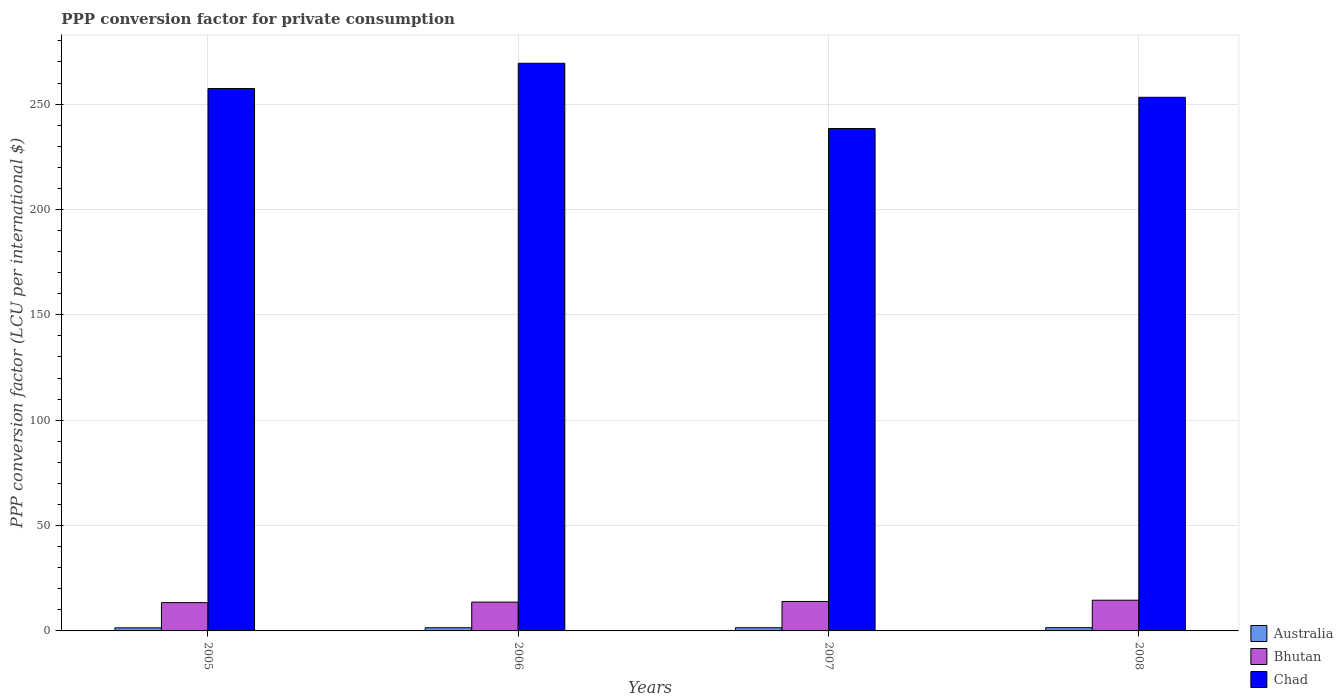How many different coloured bars are there?
Keep it short and to the point. 3. How many groups of bars are there?
Make the answer very short. 4. Are the number of bars per tick equal to the number of legend labels?
Provide a short and direct response. Yes. What is the label of the 4th group of bars from the left?
Provide a short and direct response. 2008. In how many cases, is the number of bars for a given year not equal to the number of legend labels?
Your answer should be very brief. 0. What is the PPP conversion factor for private consumption in Australia in 2007?
Make the answer very short. 1.51. Across all years, what is the maximum PPP conversion factor for private consumption in Australia?
Your answer should be compact. 1.53. Across all years, what is the minimum PPP conversion factor for private consumption in Bhutan?
Provide a succinct answer. 13.43. In which year was the PPP conversion factor for private consumption in Australia maximum?
Offer a very short reply. 2008. What is the total PPP conversion factor for private consumption in Australia in the graph?
Offer a terse response. 6. What is the difference between the PPP conversion factor for private consumption in Australia in 2006 and that in 2008?
Provide a succinct answer. -0.03. What is the difference between the PPP conversion factor for private consumption in Chad in 2005 and the PPP conversion factor for private consumption in Australia in 2006?
Give a very brief answer. 255.88. What is the average PPP conversion factor for private consumption in Bhutan per year?
Your answer should be very brief. 13.91. In the year 2008, what is the difference between the PPP conversion factor for private consumption in Chad and PPP conversion factor for private consumption in Australia?
Make the answer very short. 251.7. What is the ratio of the PPP conversion factor for private consumption in Chad in 2005 to that in 2007?
Make the answer very short. 1.08. Is the difference between the PPP conversion factor for private consumption in Chad in 2007 and 2008 greater than the difference between the PPP conversion factor for private consumption in Australia in 2007 and 2008?
Make the answer very short. No. What is the difference between the highest and the second highest PPP conversion factor for private consumption in Chad?
Your answer should be compact. 11.99. What is the difference between the highest and the lowest PPP conversion factor for private consumption in Australia?
Offer a very short reply. 0.07. In how many years, is the PPP conversion factor for private consumption in Chad greater than the average PPP conversion factor for private consumption in Chad taken over all years?
Offer a very short reply. 2. What does the 1st bar from the left in 2007 represents?
Give a very brief answer. Australia. What does the 1st bar from the right in 2008 represents?
Your answer should be very brief. Chad. How many years are there in the graph?
Your answer should be compact. 4. Are the values on the major ticks of Y-axis written in scientific E-notation?
Your answer should be very brief. No. Does the graph contain any zero values?
Provide a short and direct response. No. Does the graph contain grids?
Ensure brevity in your answer.  Yes. How many legend labels are there?
Your response must be concise. 3. How are the legend labels stacked?
Your answer should be very brief. Vertical. What is the title of the graph?
Make the answer very short. PPP conversion factor for private consumption. What is the label or title of the X-axis?
Make the answer very short. Years. What is the label or title of the Y-axis?
Offer a very short reply. PPP conversion factor (LCU per international $). What is the PPP conversion factor (LCU per international $) of Australia in 2005?
Offer a terse response. 1.46. What is the PPP conversion factor (LCU per international $) of Bhutan in 2005?
Ensure brevity in your answer.  13.43. What is the PPP conversion factor (LCU per international $) in Chad in 2005?
Offer a very short reply. 257.38. What is the PPP conversion factor (LCU per international $) of Australia in 2006?
Offer a terse response. 1.5. What is the PPP conversion factor (LCU per international $) of Bhutan in 2006?
Your answer should be very brief. 13.67. What is the PPP conversion factor (LCU per international $) in Chad in 2006?
Your answer should be very brief. 269.38. What is the PPP conversion factor (LCU per international $) in Australia in 2007?
Give a very brief answer. 1.51. What is the PPP conversion factor (LCU per international $) of Bhutan in 2007?
Provide a succinct answer. 13.97. What is the PPP conversion factor (LCU per international $) in Chad in 2007?
Provide a succinct answer. 238.4. What is the PPP conversion factor (LCU per international $) in Australia in 2008?
Offer a terse response. 1.53. What is the PPP conversion factor (LCU per international $) in Bhutan in 2008?
Keep it short and to the point. 14.58. What is the PPP conversion factor (LCU per international $) in Chad in 2008?
Offer a terse response. 253.23. Across all years, what is the maximum PPP conversion factor (LCU per international $) of Australia?
Offer a terse response. 1.53. Across all years, what is the maximum PPP conversion factor (LCU per international $) of Bhutan?
Give a very brief answer. 14.58. Across all years, what is the maximum PPP conversion factor (LCU per international $) in Chad?
Ensure brevity in your answer.  269.38. Across all years, what is the minimum PPP conversion factor (LCU per international $) in Australia?
Make the answer very short. 1.46. Across all years, what is the minimum PPP conversion factor (LCU per international $) in Bhutan?
Give a very brief answer. 13.43. Across all years, what is the minimum PPP conversion factor (LCU per international $) in Chad?
Give a very brief answer. 238.4. What is the total PPP conversion factor (LCU per international $) of Australia in the graph?
Keep it short and to the point. 6. What is the total PPP conversion factor (LCU per international $) in Bhutan in the graph?
Provide a short and direct response. 55.65. What is the total PPP conversion factor (LCU per international $) of Chad in the graph?
Keep it short and to the point. 1018.39. What is the difference between the PPP conversion factor (LCU per international $) of Australia in 2005 and that in 2006?
Your answer should be very brief. -0.03. What is the difference between the PPP conversion factor (LCU per international $) of Bhutan in 2005 and that in 2006?
Offer a very short reply. -0.23. What is the difference between the PPP conversion factor (LCU per international $) in Chad in 2005 and that in 2006?
Your answer should be very brief. -11.99. What is the difference between the PPP conversion factor (LCU per international $) of Australia in 2005 and that in 2007?
Give a very brief answer. -0.04. What is the difference between the PPP conversion factor (LCU per international $) of Bhutan in 2005 and that in 2007?
Your answer should be very brief. -0.54. What is the difference between the PPP conversion factor (LCU per international $) of Chad in 2005 and that in 2007?
Give a very brief answer. 18.98. What is the difference between the PPP conversion factor (LCU per international $) of Australia in 2005 and that in 2008?
Ensure brevity in your answer.  -0.07. What is the difference between the PPP conversion factor (LCU per international $) in Bhutan in 2005 and that in 2008?
Offer a very short reply. -1.14. What is the difference between the PPP conversion factor (LCU per international $) of Chad in 2005 and that in 2008?
Provide a short and direct response. 4.16. What is the difference between the PPP conversion factor (LCU per international $) in Australia in 2006 and that in 2007?
Provide a short and direct response. -0.01. What is the difference between the PPP conversion factor (LCU per international $) of Bhutan in 2006 and that in 2007?
Keep it short and to the point. -0.31. What is the difference between the PPP conversion factor (LCU per international $) in Chad in 2006 and that in 2007?
Offer a terse response. 30.98. What is the difference between the PPP conversion factor (LCU per international $) of Australia in 2006 and that in 2008?
Your response must be concise. -0.03. What is the difference between the PPP conversion factor (LCU per international $) of Bhutan in 2006 and that in 2008?
Make the answer very short. -0.91. What is the difference between the PPP conversion factor (LCU per international $) in Chad in 2006 and that in 2008?
Provide a short and direct response. 16.15. What is the difference between the PPP conversion factor (LCU per international $) of Australia in 2007 and that in 2008?
Ensure brevity in your answer.  -0.02. What is the difference between the PPP conversion factor (LCU per international $) of Bhutan in 2007 and that in 2008?
Provide a succinct answer. -0.6. What is the difference between the PPP conversion factor (LCU per international $) in Chad in 2007 and that in 2008?
Your answer should be compact. -14.83. What is the difference between the PPP conversion factor (LCU per international $) in Australia in 2005 and the PPP conversion factor (LCU per international $) in Bhutan in 2006?
Offer a terse response. -12.2. What is the difference between the PPP conversion factor (LCU per international $) in Australia in 2005 and the PPP conversion factor (LCU per international $) in Chad in 2006?
Offer a terse response. -267.91. What is the difference between the PPP conversion factor (LCU per international $) of Bhutan in 2005 and the PPP conversion factor (LCU per international $) of Chad in 2006?
Offer a very short reply. -255.94. What is the difference between the PPP conversion factor (LCU per international $) in Australia in 2005 and the PPP conversion factor (LCU per international $) in Bhutan in 2007?
Your answer should be very brief. -12.51. What is the difference between the PPP conversion factor (LCU per international $) in Australia in 2005 and the PPP conversion factor (LCU per international $) in Chad in 2007?
Give a very brief answer. -236.94. What is the difference between the PPP conversion factor (LCU per international $) of Bhutan in 2005 and the PPP conversion factor (LCU per international $) of Chad in 2007?
Give a very brief answer. -224.97. What is the difference between the PPP conversion factor (LCU per international $) of Australia in 2005 and the PPP conversion factor (LCU per international $) of Bhutan in 2008?
Your answer should be compact. -13.11. What is the difference between the PPP conversion factor (LCU per international $) in Australia in 2005 and the PPP conversion factor (LCU per international $) in Chad in 2008?
Offer a terse response. -251.76. What is the difference between the PPP conversion factor (LCU per international $) of Bhutan in 2005 and the PPP conversion factor (LCU per international $) of Chad in 2008?
Offer a terse response. -239.79. What is the difference between the PPP conversion factor (LCU per international $) in Australia in 2006 and the PPP conversion factor (LCU per international $) in Bhutan in 2007?
Your answer should be very brief. -12.47. What is the difference between the PPP conversion factor (LCU per international $) in Australia in 2006 and the PPP conversion factor (LCU per international $) in Chad in 2007?
Provide a succinct answer. -236.9. What is the difference between the PPP conversion factor (LCU per international $) of Bhutan in 2006 and the PPP conversion factor (LCU per international $) of Chad in 2007?
Provide a succinct answer. -224.73. What is the difference between the PPP conversion factor (LCU per international $) in Australia in 2006 and the PPP conversion factor (LCU per international $) in Bhutan in 2008?
Ensure brevity in your answer.  -13.08. What is the difference between the PPP conversion factor (LCU per international $) of Australia in 2006 and the PPP conversion factor (LCU per international $) of Chad in 2008?
Make the answer very short. -251.73. What is the difference between the PPP conversion factor (LCU per international $) in Bhutan in 2006 and the PPP conversion factor (LCU per international $) in Chad in 2008?
Your answer should be compact. -239.56. What is the difference between the PPP conversion factor (LCU per international $) of Australia in 2007 and the PPP conversion factor (LCU per international $) of Bhutan in 2008?
Give a very brief answer. -13.07. What is the difference between the PPP conversion factor (LCU per international $) of Australia in 2007 and the PPP conversion factor (LCU per international $) of Chad in 2008?
Your response must be concise. -251.72. What is the difference between the PPP conversion factor (LCU per international $) of Bhutan in 2007 and the PPP conversion factor (LCU per international $) of Chad in 2008?
Give a very brief answer. -239.25. What is the average PPP conversion factor (LCU per international $) in Australia per year?
Give a very brief answer. 1.5. What is the average PPP conversion factor (LCU per international $) of Bhutan per year?
Offer a very short reply. 13.91. What is the average PPP conversion factor (LCU per international $) in Chad per year?
Your answer should be compact. 254.6. In the year 2005, what is the difference between the PPP conversion factor (LCU per international $) in Australia and PPP conversion factor (LCU per international $) in Bhutan?
Provide a short and direct response. -11.97. In the year 2005, what is the difference between the PPP conversion factor (LCU per international $) in Australia and PPP conversion factor (LCU per international $) in Chad?
Offer a very short reply. -255.92. In the year 2005, what is the difference between the PPP conversion factor (LCU per international $) in Bhutan and PPP conversion factor (LCU per international $) in Chad?
Provide a short and direct response. -243.95. In the year 2006, what is the difference between the PPP conversion factor (LCU per international $) in Australia and PPP conversion factor (LCU per international $) in Bhutan?
Give a very brief answer. -12.17. In the year 2006, what is the difference between the PPP conversion factor (LCU per international $) in Australia and PPP conversion factor (LCU per international $) in Chad?
Your answer should be compact. -267.88. In the year 2006, what is the difference between the PPP conversion factor (LCU per international $) of Bhutan and PPP conversion factor (LCU per international $) of Chad?
Provide a short and direct response. -255.71. In the year 2007, what is the difference between the PPP conversion factor (LCU per international $) in Australia and PPP conversion factor (LCU per international $) in Bhutan?
Provide a short and direct response. -12.46. In the year 2007, what is the difference between the PPP conversion factor (LCU per international $) in Australia and PPP conversion factor (LCU per international $) in Chad?
Offer a very short reply. -236.89. In the year 2007, what is the difference between the PPP conversion factor (LCU per international $) of Bhutan and PPP conversion factor (LCU per international $) of Chad?
Give a very brief answer. -224.43. In the year 2008, what is the difference between the PPP conversion factor (LCU per international $) in Australia and PPP conversion factor (LCU per international $) in Bhutan?
Give a very brief answer. -13.04. In the year 2008, what is the difference between the PPP conversion factor (LCU per international $) in Australia and PPP conversion factor (LCU per international $) in Chad?
Your response must be concise. -251.7. In the year 2008, what is the difference between the PPP conversion factor (LCU per international $) of Bhutan and PPP conversion factor (LCU per international $) of Chad?
Ensure brevity in your answer.  -238.65. What is the ratio of the PPP conversion factor (LCU per international $) of Australia in 2005 to that in 2006?
Provide a short and direct response. 0.98. What is the ratio of the PPP conversion factor (LCU per international $) in Bhutan in 2005 to that in 2006?
Offer a very short reply. 0.98. What is the ratio of the PPP conversion factor (LCU per international $) in Chad in 2005 to that in 2006?
Provide a short and direct response. 0.96. What is the ratio of the PPP conversion factor (LCU per international $) in Australia in 2005 to that in 2007?
Offer a terse response. 0.97. What is the ratio of the PPP conversion factor (LCU per international $) in Bhutan in 2005 to that in 2007?
Your answer should be very brief. 0.96. What is the ratio of the PPP conversion factor (LCU per international $) of Chad in 2005 to that in 2007?
Your answer should be compact. 1.08. What is the ratio of the PPP conversion factor (LCU per international $) in Australia in 2005 to that in 2008?
Your answer should be compact. 0.96. What is the ratio of the PPP conversion factor (LCU per international $) of Bhutan in 2005 to that in 2008?
Keep it short and to the point. 0.92. What is the ratio of the PPP conversion factor (LCU per international $) of Chad in 2005 to that in 2008?
Provide a succinct answer. 1.02. What is the ratio of the PPP conversion factor (LCU per international $) of Bhutan in 2006 to that in 2007?
Ensure brevity in your answer.  0.98. What is the ratio of the PPP conversion factor (LCU per international $) of Chad in 2006 to that in 2007?
Provide a short and direct response. 1.13. What is the ratio of the PPP conversion factor (LCU per international $) in Australia in 2006 to that in 2008?
Your response must be concise. 0.98. What is the ratio of the PPP conversion factor (LCU per international $) of Bhutan in 2006 to that in 2008?
Provide a succinct answer. 0.94. What is the ratio of the PPP conversion factor (LCU per international $) of Chad in 2006 to that in 2008?
Your answer should be compact. 1.06. What is the ratio of the PPP conversion factor (LCU per international $) in Australia in 2007 to that in 2008?
Provide a short and direct response. 0.98. What is the ratio of the PPP conversion factor (LCU per international $) of Bhutan in 2007 to that in 2008?
Offer a terse response. 0.96. What is the ratio of the PPP conversion factor (LCU per international $) in Chad in 2007 to that in 2008?
Ensure brevity in your answer.  0.94. What is the difference between the highest and the second highest PPP conversion factor (LCU per international $) of Australia?
Offer a terse response. 0.02. What is the difference between the highest and the second highest PPP conversion factor (LCU per international $) of Bhutan?
Your answer should be compact. 0.6. What is the difference between the highest and the second highest PPP conversion factor (LCU per international $) in Chad?
Offer a very short reply. 11.99. What is the difference between the highest and the lowest PPP conversion factor (LCU per international $) of Australia?
Give a very brief answer. 0.07. What is the difference between the highest and the lowest PPP conversion factor (LCU per international $) in Bhutan?
Keep it short and to the point. 1.14. What is the difference between the highest and the lowest PPP conversion factor (LCU per international $) of Chad?
Offer a terse response. 30.98. 